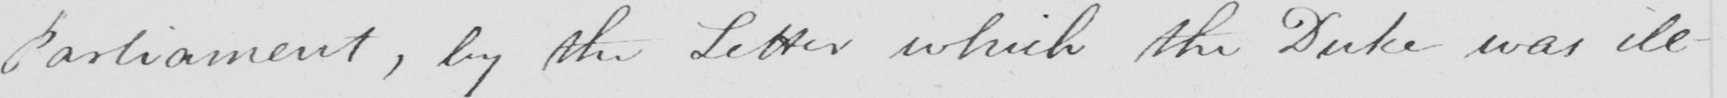What text is written in this handwritten line? Parliament , by the Letter which the Duke was ill- 